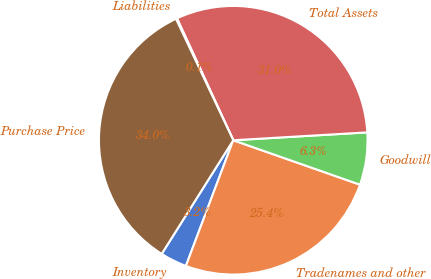<chart> <loc_0><loc_0><loc_500><loc_500><pie_chart><fcel>Inventory<fcel>Tradenames and other<fcel>Goodwill<fcel>Total Assets<fcel>Liabilities<fcel>Purchase Price<nl><fcel>3.21%<fcel>25.37%<fcel>6.3%<fcel>30.95%<fcel>0.13%<fcel>34.04%<nl></chart> 